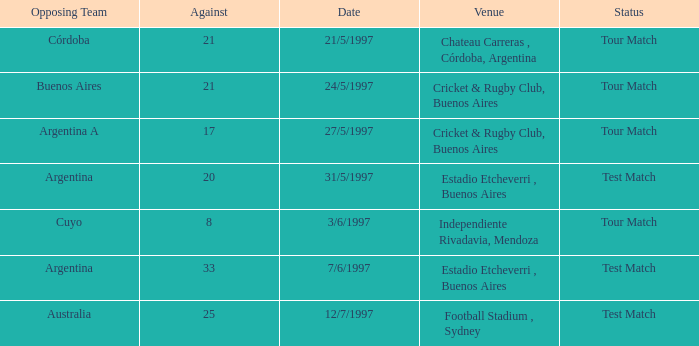I'm looking to parse the entire table for insights. Could you assist me with that? {'header': ['Opposing Team', 'Against', 'Date', 'Venue', 'Status'], 'rows': [['Córdoba', '21', '21/5/1997', 'Chateau Carreras , Córdoba, Argentina', 'Tour Match'], ['Buenos Aires', '21', '24/5/1997', 'Cricket & Rugby Club, Buenos Aires', 'Tour Match'], ['Argentina A', '17', '27/5/1997', 'Cricket & Rugby Club, Buenos Aires', 'Tour Match'], ['Argentina', '20', '31/5/1997', 'Estadio Etcheverri , Buenos Aires', 'Test Match'], ['Cuyo', '8', '3/6/1997', 'Independiente Rivadavia, Mendoza', 'Tour Match'], ['Argentina', '33', '7/6/1997', 'Estadio Etcheverri , Buenos Aires', 'Test Match'], ['Australia', '25', '12/7/1997', 'Football Stadium , Sydney', 'Test Match']]} What was the average of againsts on 21/5/1997? 21.0. 